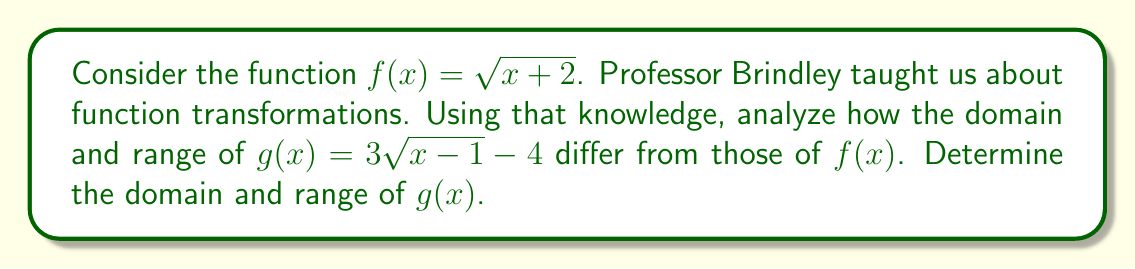What is the answer to this math problem? Let's approach this step-by-step, using the transformation techniques Professor Brindley taught us:

1) First, let's recall the domain and range of $f(x) = \sqrt{x+2}$:
   Domain: $x \geq -2$
   Range: $y \geq 0$

2) Now, let's analyze the transformations applied to $f(x)$ to get $g(x)$:
   a) Inside the square root: $(x-1)$ instead of $(x+2)$
      This is a horizontal shift 3 units to the right
   b) Outside the square root: Multiplication by 3
      This is a vertical stretch by a factor of 3
   c) Subtraction of 4 at the end
      This is a vertical shift 4 units down

3) Effect on domain:
   The horizontal shift affects the domain.
   For $f(x)$, we need $x+2 \geq 0$
   For $g(x)$, we need $x-1 \geq 0$
   Solving this: $x \geq 1$

4) Effect on range:
   The vertical stretch and shift affect the range.
   The square root is always non-negative, so $\sqrt{x-1} \geq 0$
   Multiplying by 3: $3\sqrt{x-1} \geq 0$
   Subtracting 4: $3\sqrt{x-1} - 4 \geq -4$

Therefore, the domain of $g(x)$ is $[1,\infty)$ and the range is $[-4,\infty)$.
Answer: Domain of $g(x)$: $[1,\infty)$
Range of $g(x)$: $[-4,\infty)$ 